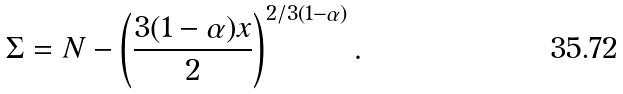Convert formula to latex. <formula><loc_0><loc_0><loc_500><loc_500>\Sigma = N - \left ( \frac { 3 ( 1 - \alpha ) x } { 2 } \right ) ^ { 2 / 3 ( 1 - \alpha ) } .</formula> 